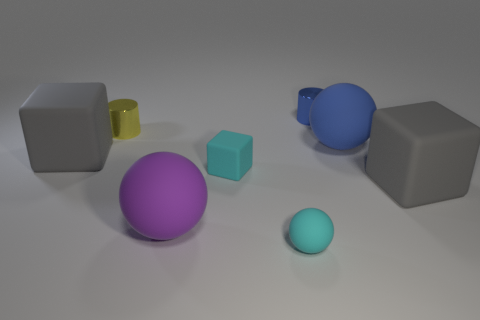What number of objects are either big rubber cubes on the right side of the blue rubber sphere or big gray objects that are right of the large blue rubber ball?
Offer a terse response. 1. How big is the rubber thing that is both behind the tiny cyan block and left of the blue metallic cylinder?
Offer a terse response. Large. There is a small yellow object; is it the same shape as the tiny blue thing that is to the right of the tiny rubber cube?
Give a very brief answer. Yes. What number of things are either gray things that are on the right side of the purple rubber sphere or cyan rubber blocks?
Your answer should be very brief. 2. Is the material of the purple ball the same as the blue object that is behind the blue rubber sphere?
Offer a very short reply. No. The blue object behind the tiny metal cylinder that is to the left of the blue shiny thing is what shape?
Your response must be concise. Cylinder. There is a small rubber sphere; does it have the same color as the tiny rubber block that is in front of the yellow cylinder?
Your answer should be compact. Yes. What is the shape of the yellow thing?
Your answer should be compact. Cylinder. How big is the yellow cylinder that is behind the big blue ball that is on the right side of the tiny rubber sphere?
Give a very brief answer. Small. Are there the same number of large blue rubber balls that are in front of the yellow cylinder and small metal cylinders in front of the blue matte thing?
Make the answer very short. No. 